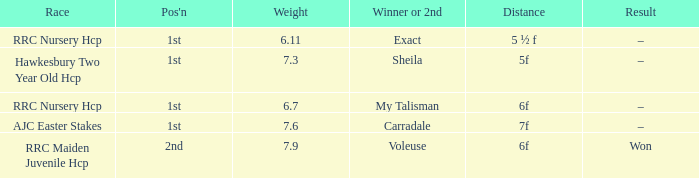What is the largest weight wth a Result of –, and a Distance of 7f? 7.6. 